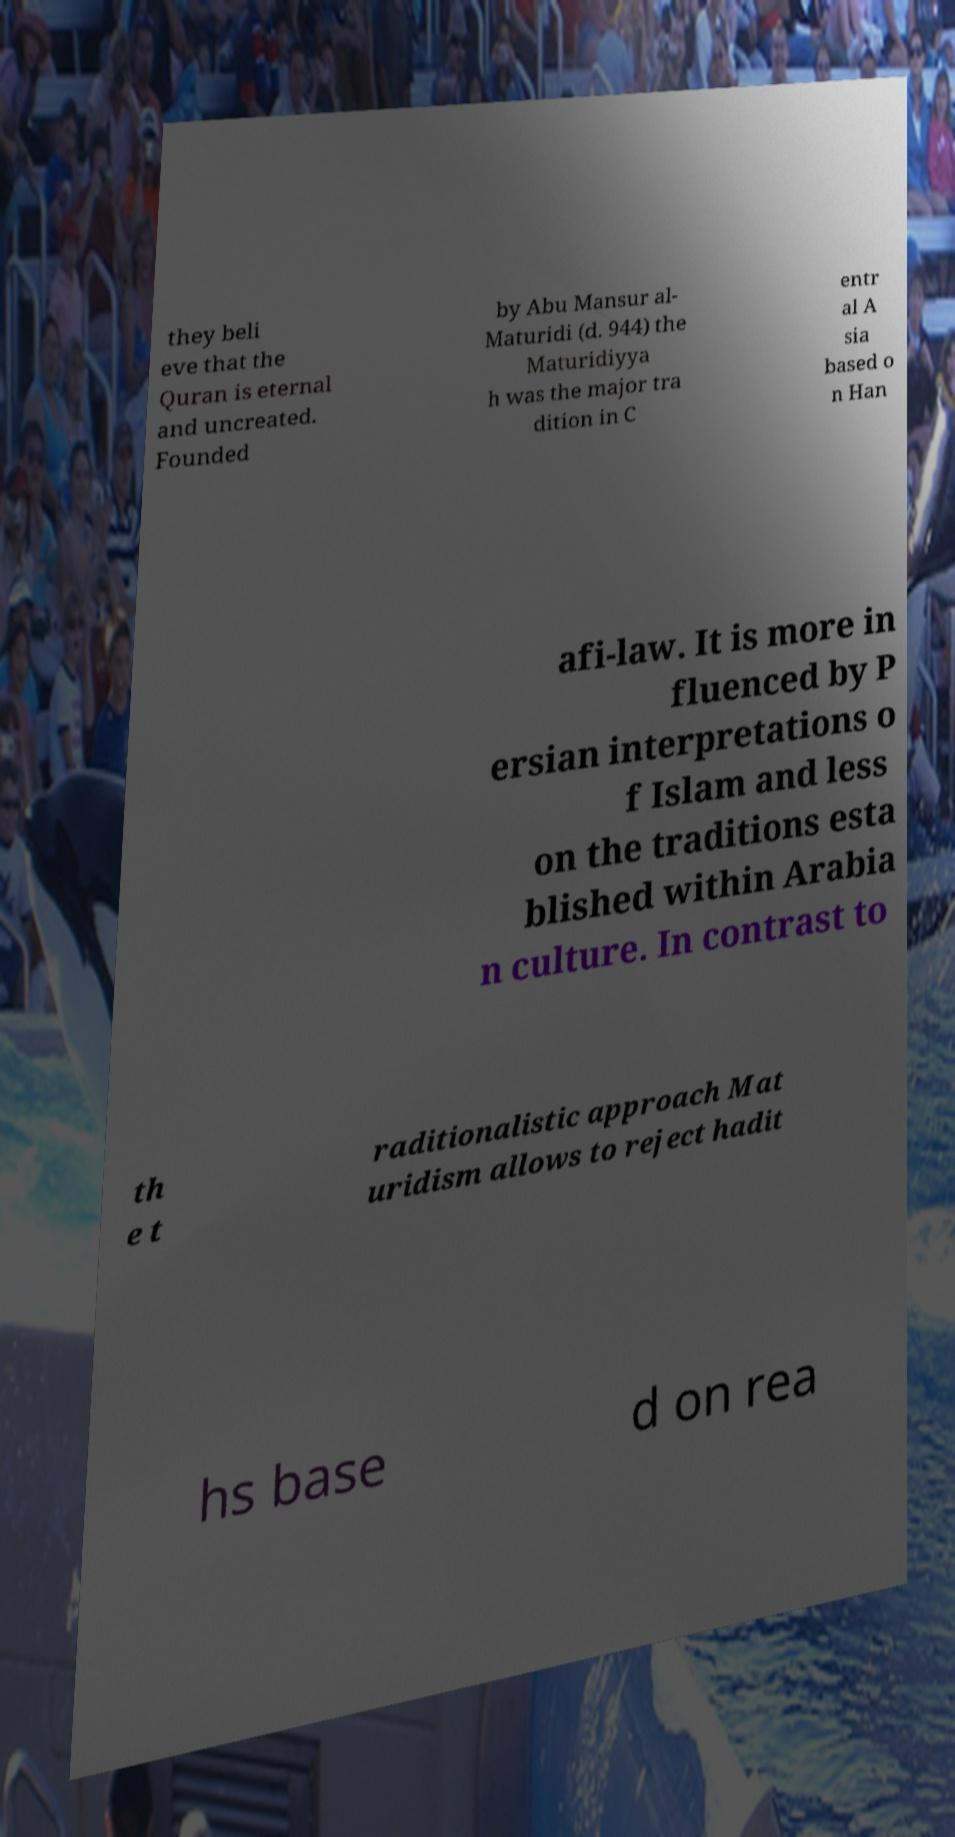Could you assist in decoding the text presented in this image and type it out clearly? they beli eve that the Quran is eternal and uncreated. Founded by Abu Mansur al- Maturidi (d. 944) the Maturidiyya h was the major tra dition in C entr al A sia based o n Han afi-law. It is more in fluenced by P ersian interpretations o f Islam and less on the traditions esta blished within Arabia n culture. In contrast to th e t raditionalistic approach Mat uridism allows to reject hadit hs base d on rea 